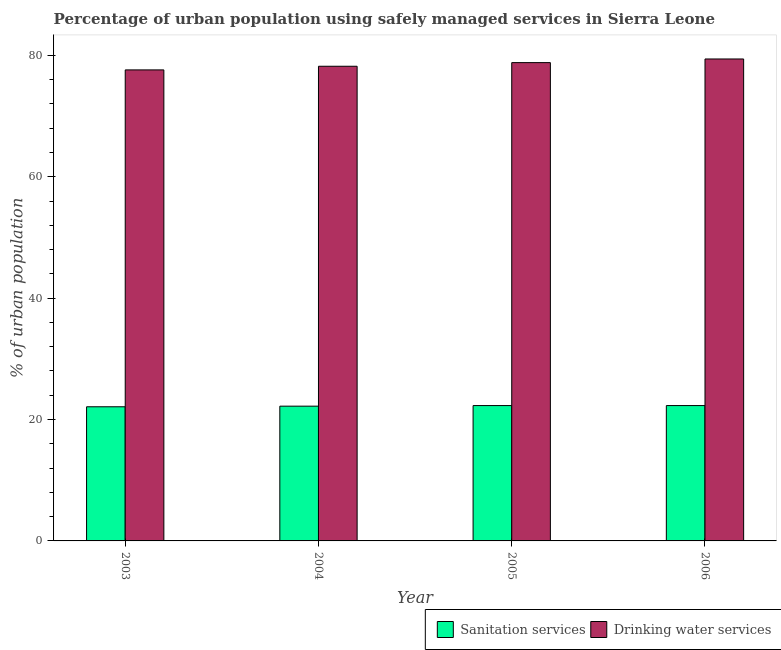How many groups of bars are there?
Give a very brief answer. 4. What is the label of the 3rd group of bars from the left?
Provide a succinct answer. 2005. In how many cases, is the number of bars for a given year not equal to the number of legend labels?
Keep it short and to the point. 0. What is the percentage of urban population who used drinking water services in 2003?
Your answer should be very brief. 77.6. Across all years, what is the maximum percentage of urban population who used sanitation services?
Make the answer very short. 22.3. Across all years, what is the minimum percentage of urban population who used drinking water services?
Your response must be concise. 77.6. In which year was the percentage of urban population who used sanitation services minimum?
Your response must be concise. 2003. What is the total percentage of urban population who used drinking water services in the graph?
Offer a terse response. 314. What is the difference between the percentage of urban population who used drinking water services in 2003 and that in 2006?
Give a very brief answer. -1.8. What is the difference between the percentage of urban population who used sanitation services in 2003 and the percentage of urban population who used drinking water services in 2004?
Provide a succinct answer. -0.1. What is the average percentage of urban population who used drinking water services per year?
Offer a very short reply. 78.5. In how many years, is the percentage of urban population who used drinking water services greater than 24 %?
Offer a terse response. 4. What is the ratio of the percentage of urban population who used sanitation services in 2004 to that in 2005?
Ensure brevity in your answer.  1. Is the difference between the percentage of urban population who used sanitation services in 2003 and 2004 greater than the difference between the percentage of urban population who used drinking water services in 2003 and 2004?
Offer a terse response. No. What is the difference between the highest and the lowest percentage of urban population who used sanitation services?
Give a very brief answer. 0.2. In how many years, is the percentage of urban population who used sanitation services greater than the average percentage of urban population who used sanitation services taken over all years?
Give a very brief answer. 2. What does the 1st bar from the left in 2004 represents?
Offer a very short reply. Sanitation services. What does the 1st bar from the right in 2005 represents?
Give a very brief answer. Drinking water services. Are the values on the major ticks of Y-axis written in scientific E-notation?
Your answer should be very brief. No. Does the graph contain grids?
Offer a terse response. No. Where does the legend appear in the graph?
Provide a short and direct response. Bottom right. How many legend labels are there?
Your answer should be compact. 2. How are the legend labels stacked?
Offer a very short reply. Horizontal. What is the title of the graph?
Give a very brief answer. Percentage of urban population using safely managed services in Sierra Leone. What is the label or title of the Y-axis?
Offer a very short reply. % of urban population. What is the % of urban population of Sanitation services in 2003?
Your answer should be compact. 22.1. What is the % of urban population of Drinking water services in 2003?
Provide a short and direct response. 77.6. What is the % of urban population in Drinking water services in 2004?
Give a very brief answer. 78.2. What is the % of urban population of Sanitation services in 2005?
Ensure brevity in your answer.  22.3. What is the % of urban population in Drinking water services in 2005?
Offer a terse response. 78.8. What is the % of urban population in Sanitation services in 2006?
Give a very brief answer. 22.3. What is the % of urban population of Drinking water services in 2006?
Give a very brief answer. 79.4. Across all years, what is the maximum % of urban population in Sanitation services?
Provide a succinct answer. 22.3. Across all years, what is the maximum % of urban population of Drinking water services?
Your response must be concise. 79.4. Across all years, what is the minimum % of urban population of Sanitation services?
Provide a short and direct response. 22.1. Across all years, what is the minimum % of urban population of Drinking water services?
Give a very brief answer. 77.6. What is the total % of urban population of Sanitation services in the graph?
Offer a terse response. 88.9. What is the total % of urban population in Drinking water services in the graph?
Your answer should be compact. 314. What is the difference between the % of urban population of Sanitation services in 2003 and that in 2004?
Provide a short and direct response. -0.1. What is the difference between the % of urban population in Drinking water services in 2003 and that in 2004?
Give a very brief answer. -0.6. What is the difference between the % of urban population of Sanitation services in 2003 and that in 2005?
Your response must be concise. -0.2. What is the difference between the % of urban population of Drinking water services in 2003 and that in 2005?
Your response must be concise. -1.2. What is the difference between the % of urban population in Drinking water services in 2003 and that in 2006?
Offer a terse response. -1.8. What is the difference between the % of urban population of Sanitation services in 2004 and that in 2005?
Provide a short and direct response. -0.1. What is the difference between the % of urban population of Drinking water services in 2004 and that in 2005?
Provide a short and direct response. -0.6. What is the difference between the % of urban population of Drinking water services in 2005 and that in 2006?
Make the answer very short. -0.6. What is the difference between the % of urban population of Sanitation services in 2003 and the % of urban population of Drinking water services in 2004?
Offer a very short reply. -56.1. What is the difference between the % of urban population in Sanitation services in 2003 and the % of urban population in Drinking water services in 2005?
Give a very brief answer. -56.7. What is the difference between the % of urban population of Sanitation services in 2003 and the % of urban population of Drinking water services in 2006?
Offer a very short reply. -57.3. What is the difference between the % of urban population in Sanitation services in 2004 and the % of urban population in Drinking water services in 2005?
Make the answer very short. -56.6. What is the difference between the % of urban population in Sanitation services in 2004 and the % of urban population in Drinking water services in 2006?
Your answer should be very brief. -57.2. What is the difference between the % of urban population in Sanitation services in 2005 and the % of urban population in Drinking water services in 2006?
Provide a succinct answer. -57.1. What is the average % of urban population in Sanitation services per year?
Your answer should be very brief. 22.23. What is the average % of urban population in Drinking water services per year?
Your response must be concise. 78.5. In the year 2003, what is the difference between the % of urban population of Sanitation services and % of urban population of Drinking water services?
Your answer should be compact. -55.5. In the year 2004, what is the difference between the % of urban population of Sanitation services and % of urban population of Drinking water services?
Make the answer very short. -56. In the year 2005, what is the difference between the % of urban population in Sanitation services and % of urban population in Drinking water services?
Offer a very short reply. -56.5. In the year 2006, what is the difference between the % of urban population of Sanitation services and % of urban population of Drinking water services?
Your answer should be compact. -57.1. What is the ratio of the % of urban population in Drinking water services in 2003 to that in 2004?
Provide a short and direct response. 0.99. What is the ratio of the % of urban population of Sanitation services in 2003 to that in 2005?
Offer a very short reply. 0.99. What is the ratio of the % of urban population in Sanitation services in 2003 to that in 2006?
Offer a terse response. 0.99. What is the ratio of the % of urban population in Drinking water services in 2003 to that in 2006?
Ensure brevity in your answer.  0.98. What is the ratio of the % of urban population in Sanitation services in 2004 to that in 2005?
Your response must be concise. 1. What is the ratio of the % of urban population of Sanitation services in 2004 to that in 2006?
Provide a succinct answer. 1. What is the ratio of the % of urban population of Drinking water services in 2004 to that in 2006?
Offer a very short reply. 0.98. What is the ratio of the % of urban population in Drinking water services in 2005 to that in 2006?
Offer a terse response. 0.99. What is the difference between the highest and the lowest % of urban population of Sanitation services?
Provide a succinct answer. 0.2. What is the difference between the highest and the lowest % of urban population of Drinking water services?
Ensure brevity in your answer.  1.8. 